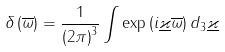Convert formula to latex. <formula><loc_0><loc_0><loc_500><loc_500>\delta \left ( \overline { \omega } \right ) = \frac { 1 } { \left ( 2 \pi \right ) ^ { 3 } } \int \exp \left ( i \underline { \varkappa } \overline { \omega } \right ) d _ { 3 } \underline { \varkappa }</formula> 